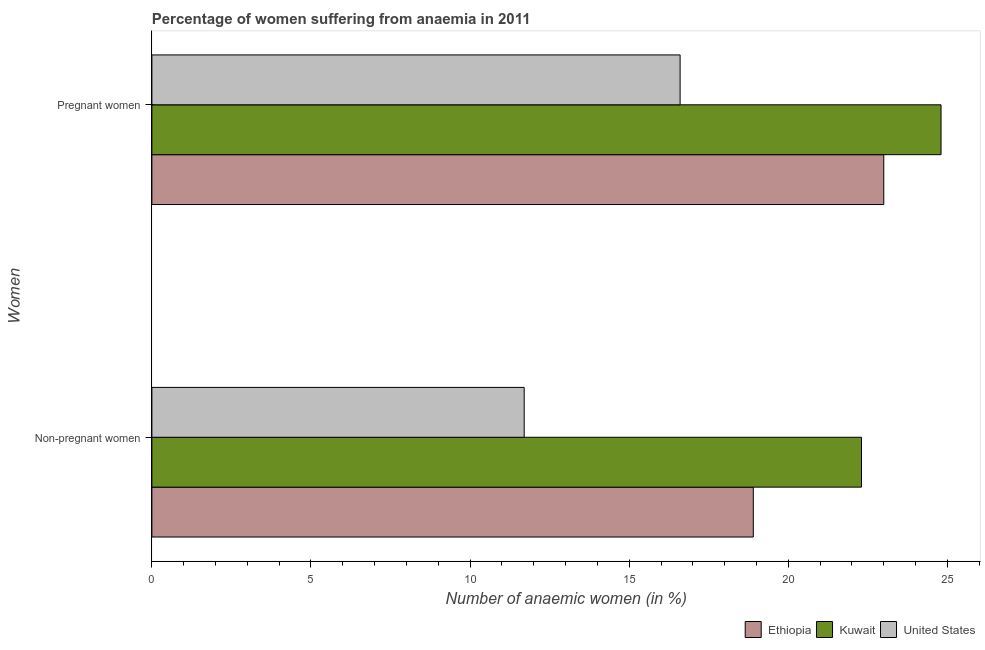How many different coloured bars are there?
Your answer should be compact. 3. How many groups of bars are there?
Your answer should be very brief. 2. How many bars are there on the 2nd tick from the top?
Provide a succinct answer. 3. How many bars are there on the 1st tick from the bottom?
Make the answer very short. 3. What is the label of the 1st group of bars from the top?
Make the answer very short. Pregnant women. What is the percentage of pregnant anaemic women in Ethiopia?
Your response must be concise. 23. Across all countries, what is the maximum percentage of pregnant anaemic women?
Give a very brief answer. 24.8. In which country was the percentage of pregnant anaemic women maximum?
Your response must be concise. Kuwait. What is the total percentage of pregnant anaemic women in the graph?
Your answer should be very brief. 64.4. What is the difference between the percentage of pregnant anaemic women in United States and the percentage of non-pregnant anaemic women in Ethiopia?
Make the answer very short. -2.3. What is the average percentage of pregnant anaemic women per country?
Your response must be concise. 21.47. What is the ratio of the percentage of non-pregnant anaemic women in Kuwait to that in Ethiopia?
Keep it short and to the point. 1.18. What does the 1st bar from the bottom in Pregnant women represents?
Make the answer very short. Ethiopia. How many bars are there?
Make the answer very short. 6. Are all the bars in the graph horizontal?
Ensure brevity in your answer.  Yes. Does the graph contain grids?
Offer a terse response. No. What is the title of the graph?
Provide a succinct answer. Percentage of women suffering from anaemia in 2011. Does "Nicaragua" appear as one of the legend labels in the graph?
Your answer should be compact. No. What is the label or title of the X-axis?
Your answer should be compact. Number of anaemic women (in %). What is the label or title of the Y-axis?
Make the answer very short. Women. What is the Number of anaemic women (in %) in Kuwait in Non-pregnant women?
Provide a succinct answer. 22.3. What is the Number of anaemic women (in %) in Kuwait in Pregnant women?
Make the answer very short. 24.8. What is the Number of anaemic women (in %) in United States in Pregnant women?
Ensure brevity in your answer.  16.6. Across all Women, what is the maximum Number of anaemic women (in %) in Kuwait?
Your answer should be very brief. 24.8. Across all Women, what is the minimum Number of anaemic women (in %) in Ethiopia?
Keep it short and to the point. 18.9. Across all Women, what is the minimum Number of anaemic women (in %) of Kuwait?
Offer a very short reply. 22.3. What is the total Number of anaemic women (in %) of Ethiopia in the graph?
Your answer should be very brief. 41.9. What is the total Number of anaemic women (in %) of Kuwait in the graph?
Offer a terse response. 47.1. What is the total Number of anaemic women (in %) of United States in the graph?
Offer a very short reply. 28.3. What is the difference between the Number of anaemic women (in %) of Kuwait in Non-pregnant women and that in Pregnant women?
Offer a terse response. -2.5. What is the difference between the Number of anaemic women (in %) of United States in Non-pregnant women and that in Pregnant women?
Ensure brevity in your answer.  -4.9. What is the difference between the Number of anaemic women (in %) of Ethiopia in Non-pregnant women and the Number of anaemic women (in %) of Kuwait in Pregnant women?
Keep it short and to the point. -5.9. What is the difference between the Number of anaemic women (in %) of Ethiopia in Non-pregnant women and the Number of anaemic women (in %) of United States in Pregnant women?
Make the answer very short. 2.3. What is the difference between the Number of anaemic women (in %) in Kuwait in Non-pregnant women and the Number of anaemic women (in %) in United States in Pregnant women?
Give a very brief answer. 5.7. What is the average Number of anaemic women (in %) in Ethiopia per Women?
Ensure brevity in your answer.  20.95. What is the average Number of anaemic women (in %) in Kuwait per Women?
Keep it short and to the point. 23.55. What is the average Number of anaemic women (in %) in United States per Women?
Your answer should be compact. 14.15. What is the difference between the Number of anaemic women (in %) of Ethiopia and Number of anaemic women (in %) of Kuwait in Non-pregnant women?
Your response must be concise. -3.4. What is the difference between the Number of anaemic women (in %) of Ethiopia and Number of anaemic women (in %) of United States in Pregnant women?
Your response must be concise. 6.4. What is the ratio of the Number of anaemic women (in %) in Ethiopia in Non-pregnant women to that in Pregnant women?
Your answer should be compact. 0.82. What is the ratio of the Number of anaemic women (in %) of Kuwait in Non-pregnant women to that in Pregnant women?
Your answer should be compact. 0.9. What is the ratio of the Number of anaemic women (in %) of United States in Non-pregnant women to that in Pregnant women?
Provide a short and direct response. 0.7. What is the difference between the highest and the second highest Number of anaemic women (in %) in Kuwait?
Ensure brevity in your answer.  2.5. What is the difference between the highest and the lowest Number of anaemic women (in %) in Ethiopia?
Offer a terse response. 4.1. What is the difference between the highest and the lowest Number of anaemic women (in %) in United States?
Offer a terse response. 4.9. 